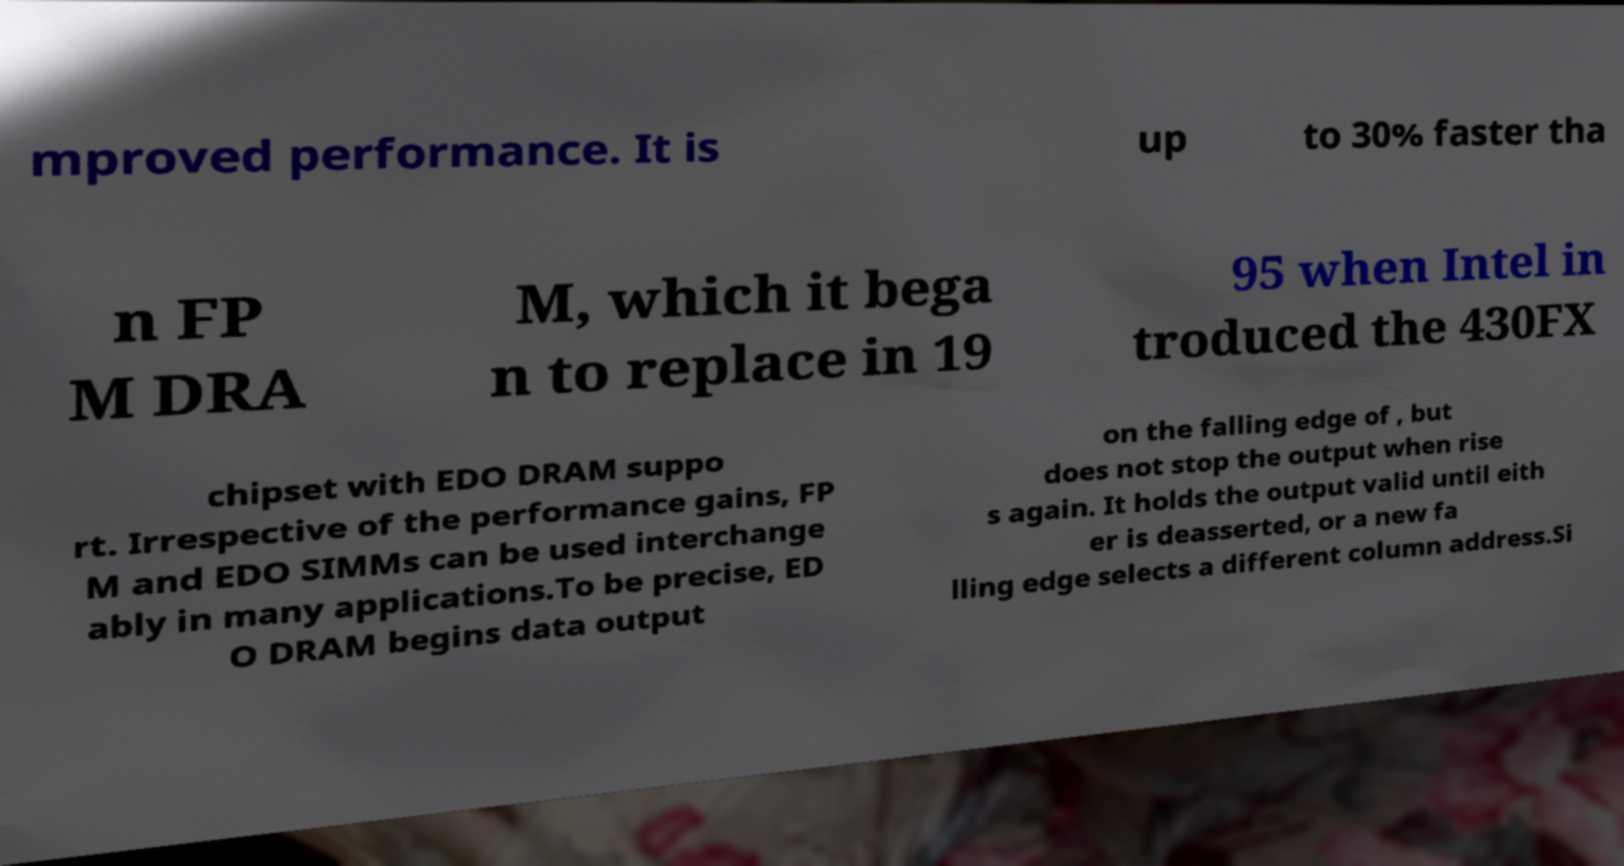Please read and relay the text visible in this image. What does it say? mproved performance. It is up to 30% faster tha n FP M DRA M, which it bega n to replace in 19 95 when Intel in troduced the 430FX chipset with EDO DRAM suppo rt. Irrespective of the performance gains, FP M and EDO SIMMs can be used interchange ably in many applications.To be precise, ED O DRAM begins data output on the falling edge of , but does not stop the output when rise s again. It holds the output valid until eith er is deasserted, or a new fa lling edge selects a different column address.Si 